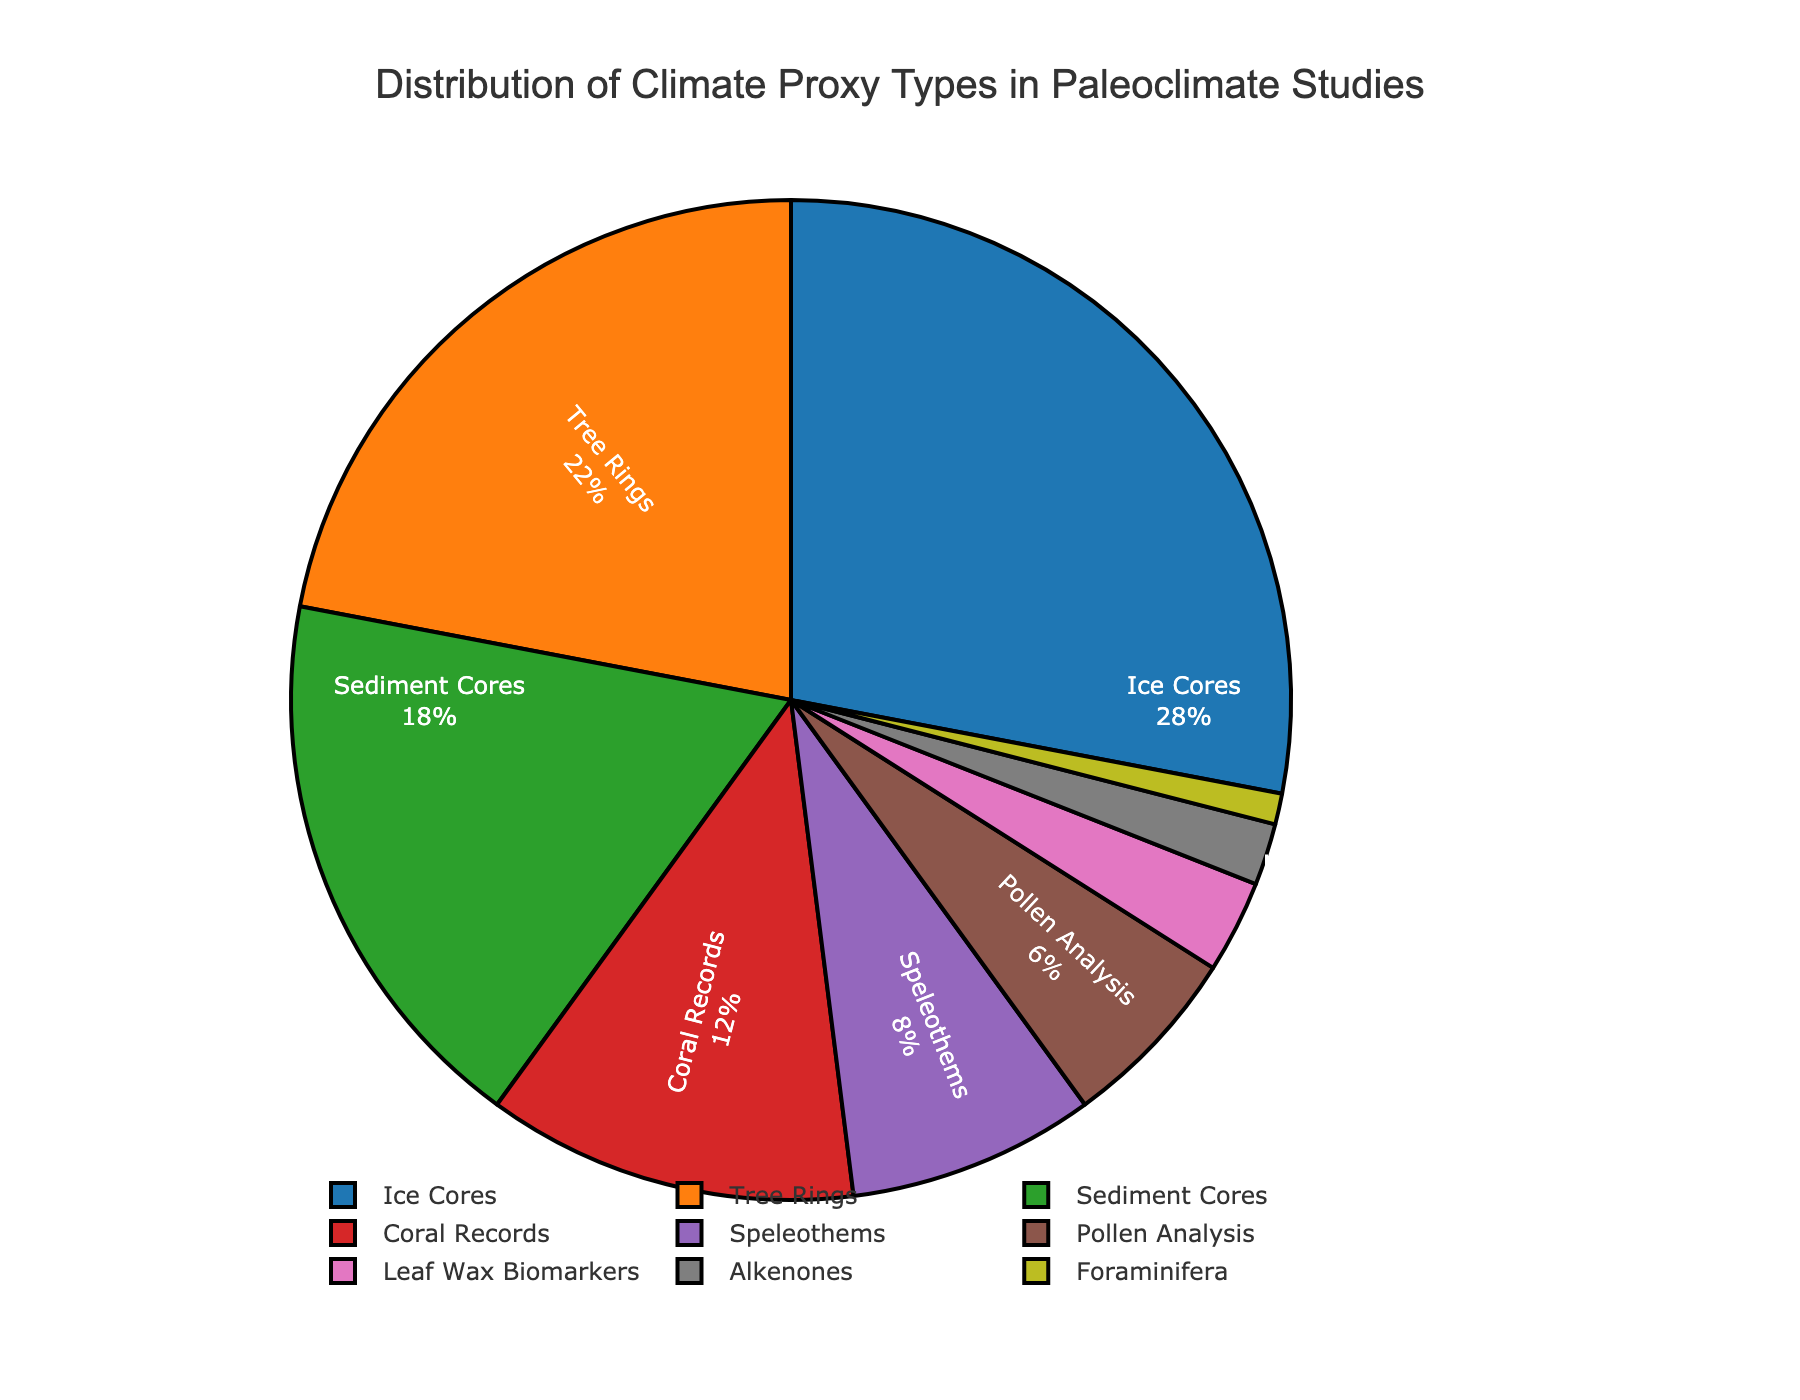What type of climate proxy is used the most in paleoclimate studies? The pie chart shows that Ice Cores occupy the largest section of the pie chart, indicating that they are the most used climate proxy in paleoclimate studies.
Answer: Ice Cores Which two climate proxy types are used least in paleoclimate studies, and what are their combined percentages? The chart indicates that Foraminifera and Alkenones have the smallest sections. Their percentages are 1% and 2%, respectively. The combined percentage is 1% + 2% = 3%.
Answer: Foraminifera and Alkenones, 3% Are Tree Rings used more than Coral Records in paleoclimate studies? By comparing sections of the pie chart, we see that Tree Rings (22%) occupy a larger section compared to Coral Records (12%).
Answer: Yes How much larger is the percentage of Ice Cores than Speleothems? The percentage of Ice Cores is 28%, and the percentage of Speleothems is 8%. The difference is 28% - 8% = 20%.
Answer: 20% Which three climate proxy types together account for more than half of the total studies? The pie chart segments indicate that Ice Cores (28%) and Tree Rings (22%) together make 28% + 22% = 50%. Adding Sediment Cores (18%) results in 50% + 18% = 68%, which is more than half.
Answer: Ice Cores, Tree Rings, and Sediment Cores How do the percentages of Pollen Analysis and Leaf Wax Biomarkers compare? The pie chart shows percentages of 6% for Pollen Analysis and 3% for Leaf Wax Biomarkers. Pollen Analysis has double the percentage of Leaf Wax Biomarkers.
Answer: Pollen Analysis is twice as much as Leaf Wax Biomarkers What percentage of climate proxy types is represented by Coral Records, Speleothems, and Pollen Analysis combined? The individual percentages are Coral Records (12%), Speleothems (8%), and Pollen Analysis (6%). Their combined percentage is 12% + 8% + 6% = 26%.
Answer: 26% Considering the top four climate proxy types, what percentage do they contribute together? The top four percentages from the chart are Ice Cores (28%), Tree Rings (22%), Sediment Cores (18%), and Coral Records (12%). Their total is 28% + 22% + 18% + 12% = 80%.
Answer: 80% If you combine the percentages of Alkenones and Foraminifera, do they exceed any individual climate proxy type? The combined percentage of Alkenones (2%) and Foraminifera (1%) is 3%. Comparing this with individual types, 3% does not exceed any individual proxy types listed on the chart.
Answer: No What proportion of the climate proxy types does Sediment Cores and Tree Rings together represent? According to the chart, Sediment Cores represent 18% and Tree Rings represent 22%. Together they account for 18% + 22% = 40%.
Answer: 40% 